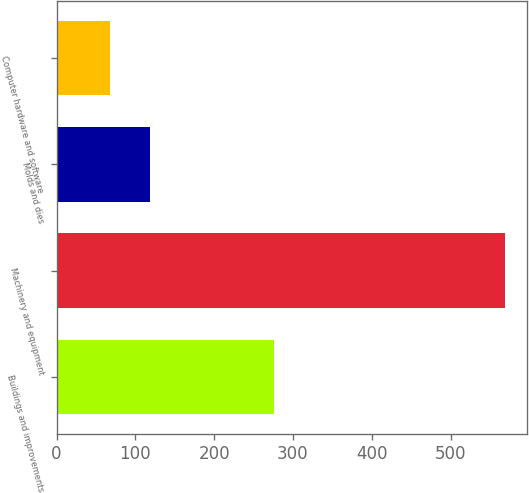Convert chart to OTSL. <chart><loc_0><loc_0><loc_500><loc_500><bar_chart><fcel>Buildings and improvements<fcel>Machinery and equipment<fcel>Molds and dies<fcel>Computer hardware and software<nl><fcel>276.4<fcel>568.7<fcel>118.25<fcel>68.2<nl></chart> 